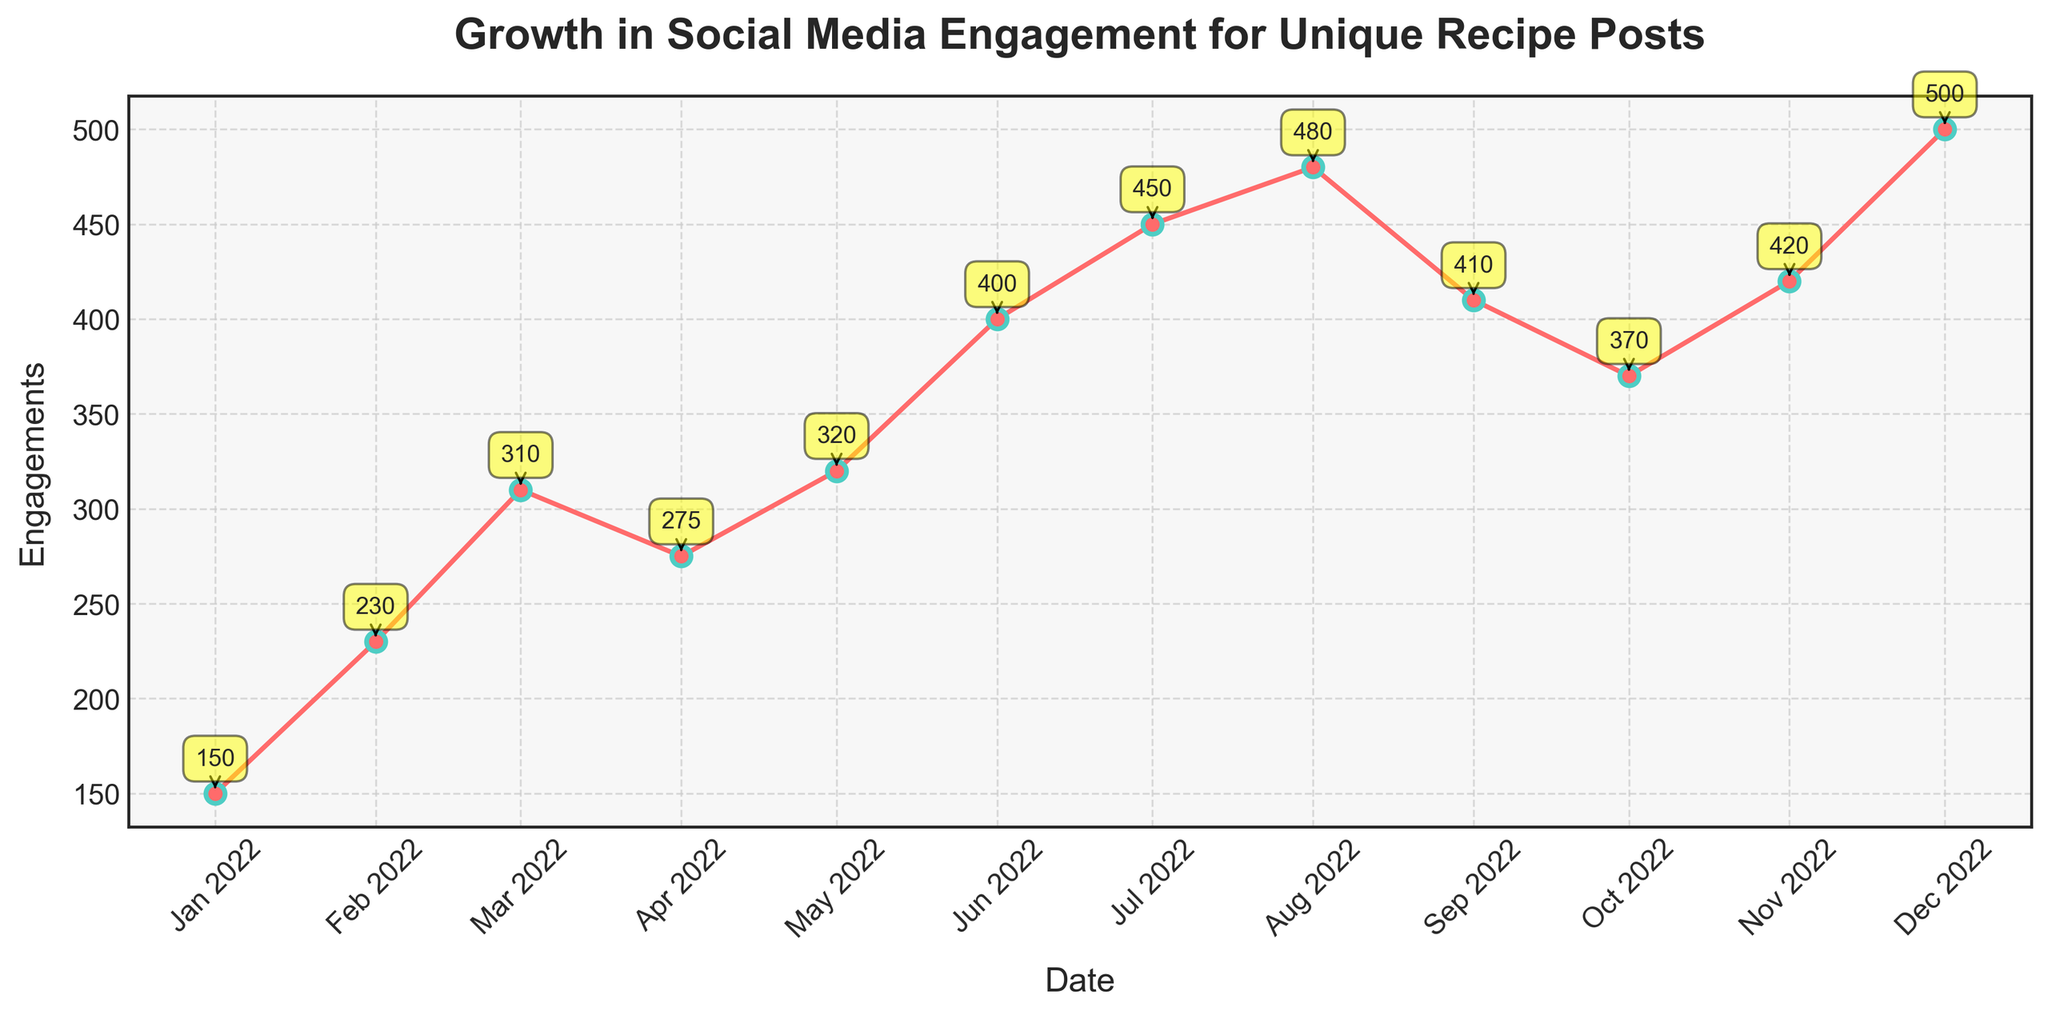What is the title of the plot? The title of the plot is displayed at the top of the figure and is usually written in larger, bold font to help identify the subject of the plot. In this case, it reads 'Growth in Social Media Engagement for Unique Recipe Posts'.
Answer: Growth in Social Media Engagement for Unique Recipe Posts How many data points are plotted on the figure? The figure shows 12 points, each corresponding to a unique recipe post from different months in the year 2022. These points are marked by small circles on the time series line.
Answer: 12 What is the highest engagement value, and for which recipe post does it occur? By looking at the vertical axis (engagements) and the annotations next to each data point, we can see that the highest engagement value is 500. This value corresponds to the 'Ant Egg Salsa from Mexico' post in December 2022.
Answer: 500, Ant Egg Salsa from Mexico What is the difference in engagements between 'Fried Tarantulas from Cambodia' and 'Lutefisk from Norway'? From the annotations, 'Fried Tarantulas from Cambodia' has 400 engagements, and 'Lutefisk from Norway' has 410 engagements. The difference is 410 - 400.
Answer: 10 Which recipe post experienced the most significant decrease in engagements from the previous month? By examining the annotations and looking for the month-to-month differences in engagement values, 'Hákarl from Iceland' in October 2022 had 370 engagements, down from 'Lutefisk from Norway' in September 2022, which had 410 engagements. The decrease is 410 - 370.
Answer: Hákarl from Iceland What is the average number of engagements across all posts for the eight months from January to August? The engagement values for the first eight months are 150, 230, 310, 275, 320, 400, 450, and 480. Summing these values gives 2615. Dividing this by 8 (the number of months) gives the average. 2615 / 8 = 326.875
Answer: 326.875 Which month had the lowest engagement, and what was the engagement value? By looking at the vertical axis and the annotations, January 2022 had the lowest engagement with 150.
Answer: January 2022, 150 Which month showed the highest month-to-month increase in engagement? To find the highest increase, we look at the differences between consecutive months. The highest increase is from July 2022 (450) to August 2022 (480), which is 30.
Answer: August 2022 Is the engagement trend generally increasing, decreasing, or fluctuating throughout the year? Observing the plotted line, we notice both increases and decreases, with a general upward trend peaking in August 2022 before fluctuating towards the end of the year.
Answer: Fluctuating What is the total engagement count for all the posts combined throughout the year? By summing all the engagement annotations from each month, 150 + 230 + 310 + 275 + 320 + 400 + 450 + 480 + 410 + 370 + 420 + 500, we get the total engagements.
Answer: 4315 